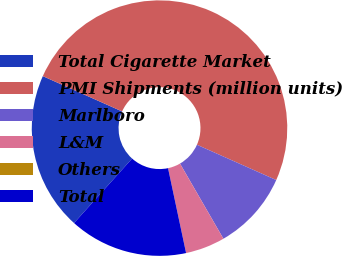Convert chart to OTSL. <chart><loc_0><loc_0><loc_500><loc_500><pie_chart><fcel>Total Cigarette Market<fcel>PMI Shipments (million units)<fcel>Marlboro<fcel>L&M<fcel>Others<fcel>Total<nl><fcel>20.0%<fcel>49.99%<fcel>10.0%<fcel>5.0%<fcel>0.0%<fcel>15.0%<nl></chart> 